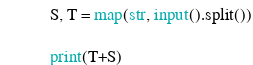<code> <loc_0><loc_0><loc_500><loc_500><_Python_>S, T = map(str, input().split())

print(T+S)</code> 